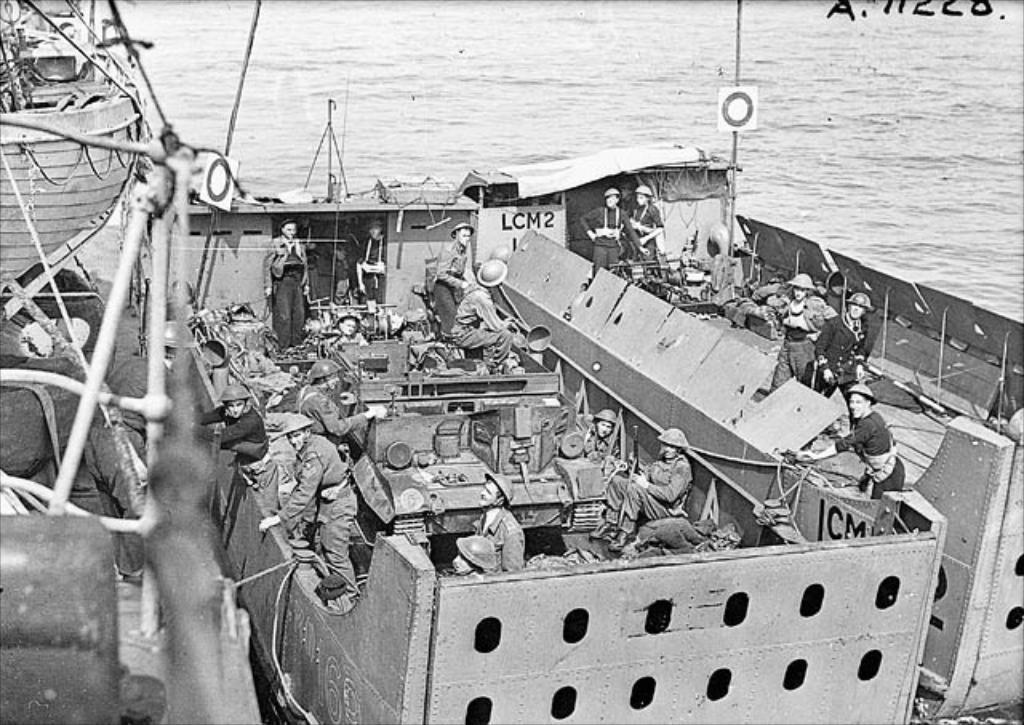Describe this image in one or two sentences. In the foreground we can see ships, people, army tank and various objects. At the top there is a water body. 